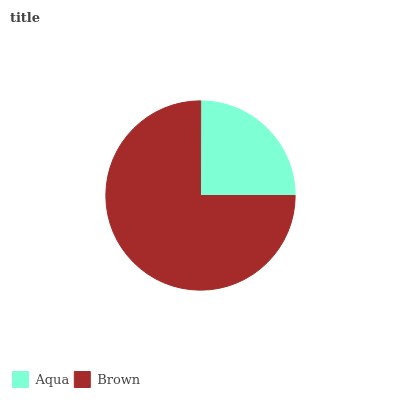Is Aqua the minimum?
Answer yes or no. Yes. Is Brown the maximum?
Answer yes or no. Yes. Is Brown the minimum?
Answer yes or no. No. Is Brown greater than Aqua?
Answer yes or no. Yes. Is Aqua less than Brown?
Answer yes or no. Yes. Is Aqua greater than Brown?
Answer yes or no. No. Is Brown less than Aqua?
Answer yes or no. No. Is Brown the high median?
Answer yes or no. Yes. Is Aqua the low median?
Answer yes or no. Yes. Is Aqua the high median?
Answer yes or no. No. Is Brown the low median?
Answer yes or no. No. 